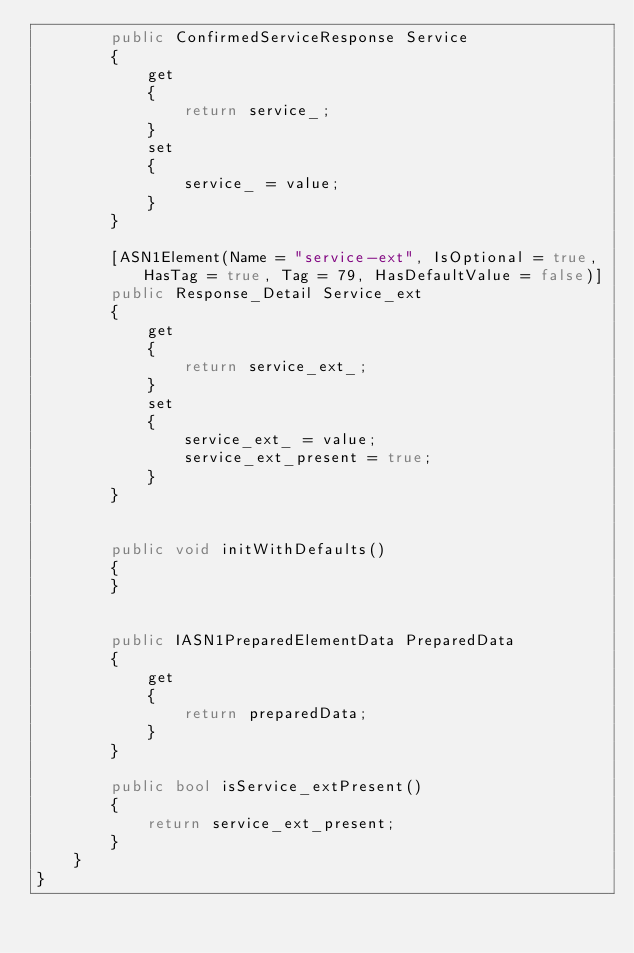Convert code to text. <code><loc_0><loc_0><loc_500><loc_500><_C#_>        public ConfirmedServiceResponse Service
        {
            get
            {
                return service_;
            }
            set
            {
                service_ = value;
            }
        }

        [ASN1Element(Name = "service-ext", IsOptional = true, HasTag = true, Tag = 79, HasDefaultValue = false)]
        public Response_Detail Service_ext
        {
            get
            {
                return service_ext_;
            }
            set
            {
                service_ext_ = value;
                service_ext_present = true;
            }
        }


        public void initWithDefaults()
        {
        }


        public IASN1PreparedElementData PreparedData
        {
            get
            {
                return preparedData;
            }
        }

        public bool isService_extPresent()
        {
            return service_ext_present;
        }
    }
}</code> 